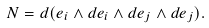<formula> <loc_0><loc_0><loc_500><loc_500>N = d ( e _ { i } \wedge d e _ { i } \wedge d e _ { j } \wedge d e _ { j } ) .</formula> 